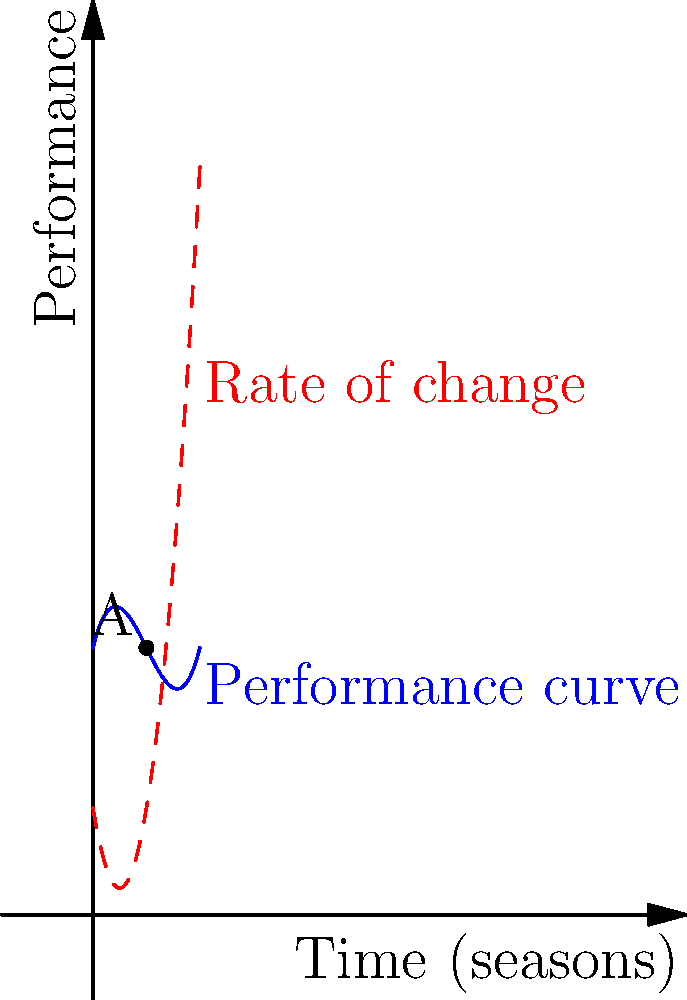The graph shows a player's performance curve (blue) and its rate of change (red dashed) over several seasons. At point A, which corresponds to the 2nd season, the player's performance is given by $f(2) = 10$ and the rate of change is $g(2) = 4$. If $f(x) = 0.5x^3 - 3x^2 + 4x + 10$, where $x$ represents the number of seasons, determine the instantaneous rate of change in the player's performance at the start of the 3rd season. To find the instantaneous rate of change at the start of the 3rd season, we need to follow these steps:

1) The rate of change is given by the derivative of the performance function $f(x)$.

2) Let's find $f'(x)$:
   $f(x) = 0.5x^3 - 3x^2 + 4x + 10$
   $f'(x) = 1.5x^2 - 6x + 4$

3) The start of the 3rd season corresponds to $x = 3$.

4) Now, we evaluate $f'(3)$:
   $f'(3) = 1.5(3)^2 - 6(3) + 4$
   $f'(3) = 1.5(9) - 18 + 4$
   $f'(3) = 13.5 - 18 + 4$
   $f'(3) = -0.5$

5) Therefore, the instantaneous rate of change at the start of the 3rd season is -0.5.

This negative value indicates that the player's performance is decreasing at this point, which aligns with the graph where we can see the performance curve (blue) is declining around $x = 3$.
Answer: $-0.5$ 